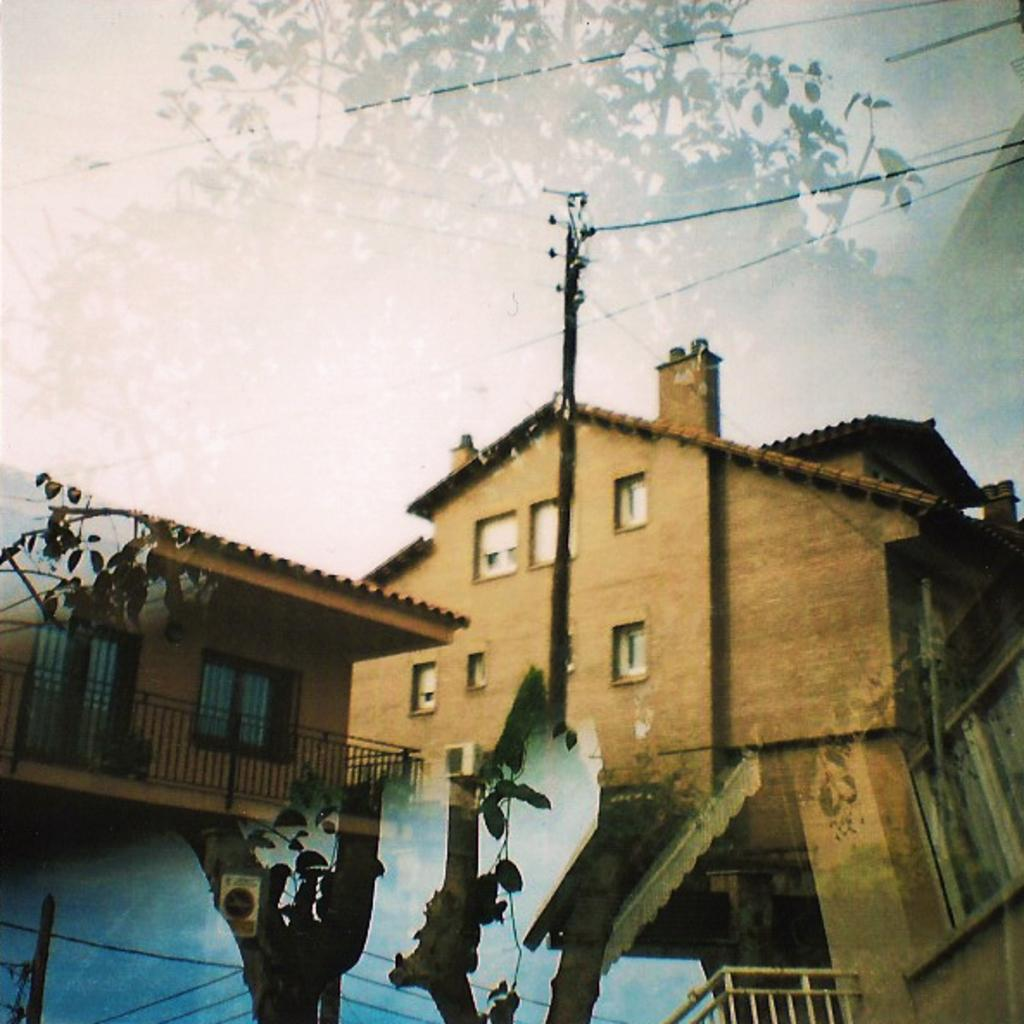What type of structures can be seen in the image? There are buildings in the image. What else can be seen in the image besides buildings? There are poles, wires, trees, and the sky visible in the image. What does the kitty smell like in the image? There is no kitty present in the image, so it is not possible to determine what it might smell like. What are the hands doing in the image? There are no hands visible in the image. 